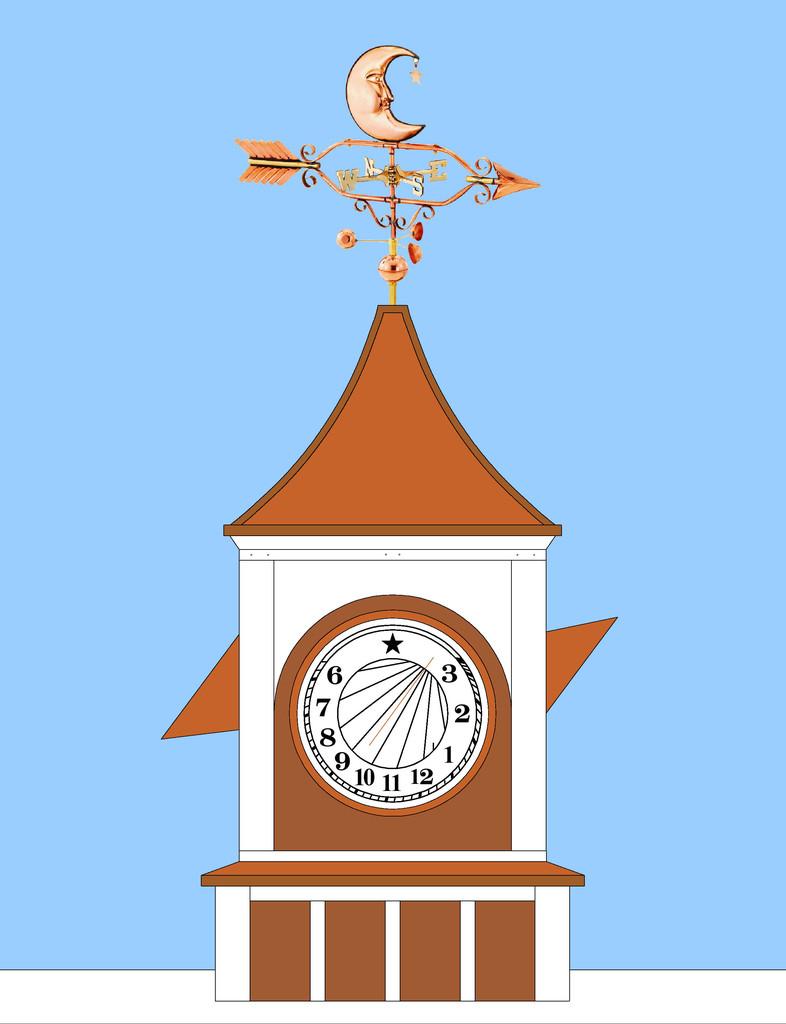What numbers are shown on this?
Provide a succinct answer. 3 2 1 12 11 10 9 8 7 6. What is the number at the bottom of the clock?
Provide a short and direct response. 11. 